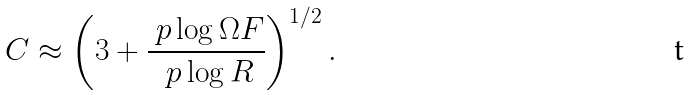<formula> <loc_0><loc_0><loc_500><loc_500>C \approx \left ( 3 + \frac { \ p \log \Omega F } { \ p \log R } \right ) ^ { 1 / 2 } .</formula> 